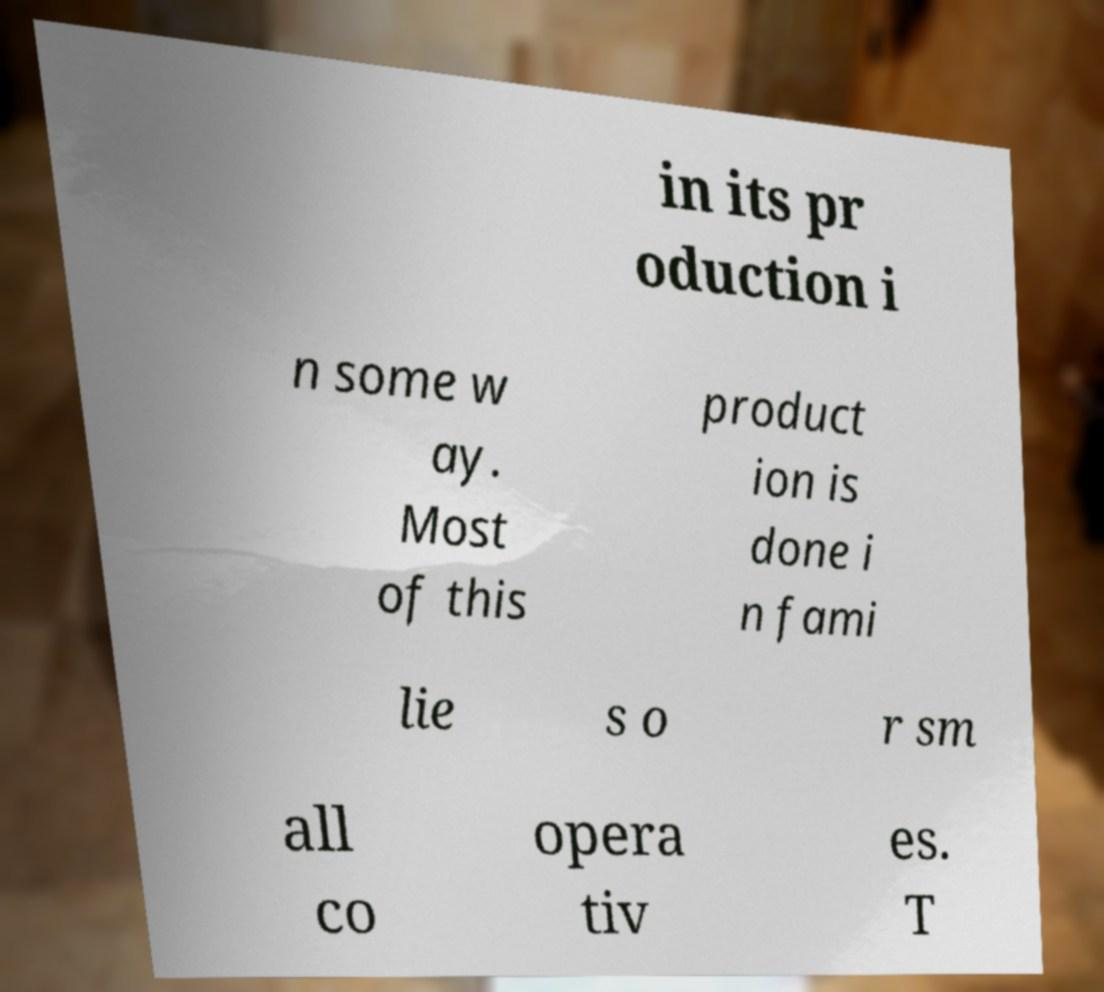Could you extract and type out the text from this image? in its pr oduction i n some w ay. Most of this product ion is done i n fami lie s o r sm all co opera tiv es. T 